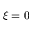Convert formula to latex. <formula><loc_0><loc_0><loc_500><loc_500>\xi = 0</formula> 